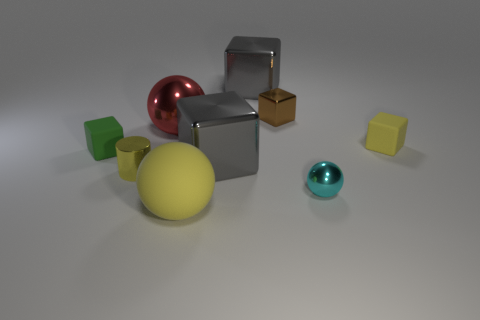Subtract all yellow matte cubes. How many cubes are left? 4 Subtract all brown cubes. How many cubes are left? 4 Subtract all red cubes. Subtract all green spheres. How many cubes are left? 5 Add 1 brown shiny cubes. How many objects exist? 10 Subtract all cylinders. How many objects are left? 8 Subtract 1 yellow cylinders. How many objects are left? 8 Subtract all tiny metallic cubes. Subtract all large cyan rubber cylinders. How many objects are left? 8 Add 3 tiny cyan things. How many tiny cyan things are left? 4 Add 4 cyan metallic spheres. How many cyan metallic spheres exist? 5 